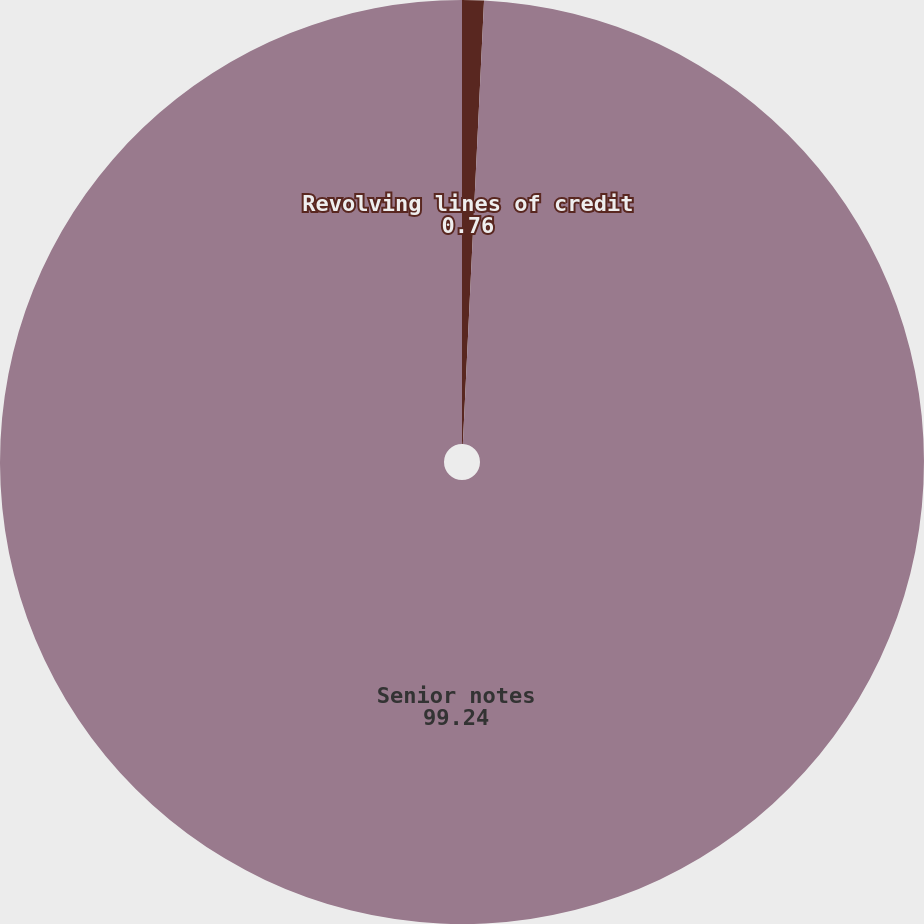Convert chart. <chart><loc_0><loc_0><loc_500><loc_500><pie_chart><fcel>Revolving lines of credit<fcel>Senior notes<nl><fcel>0.76%<fcel>99.24%<nl></chart> 